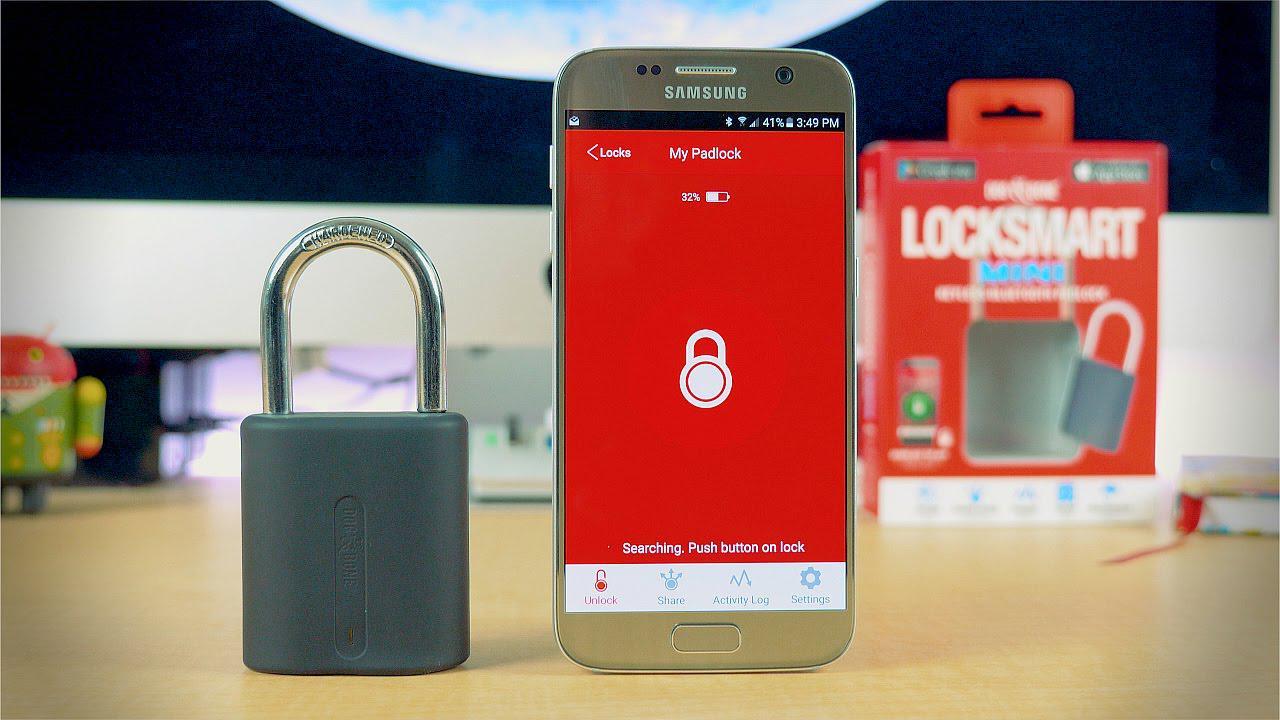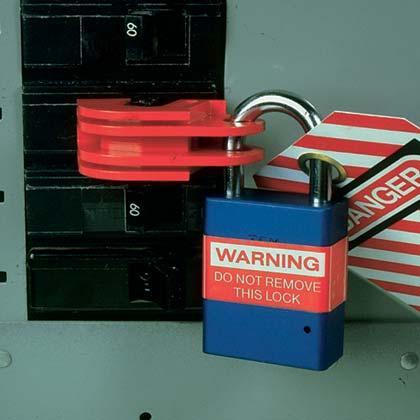The first image is the image on the left, the second image is the image on the right. For the images displayed, is the sentence "Red and white stripes are visible in one of the images." factually correct? Answer yes or no. Yes. 